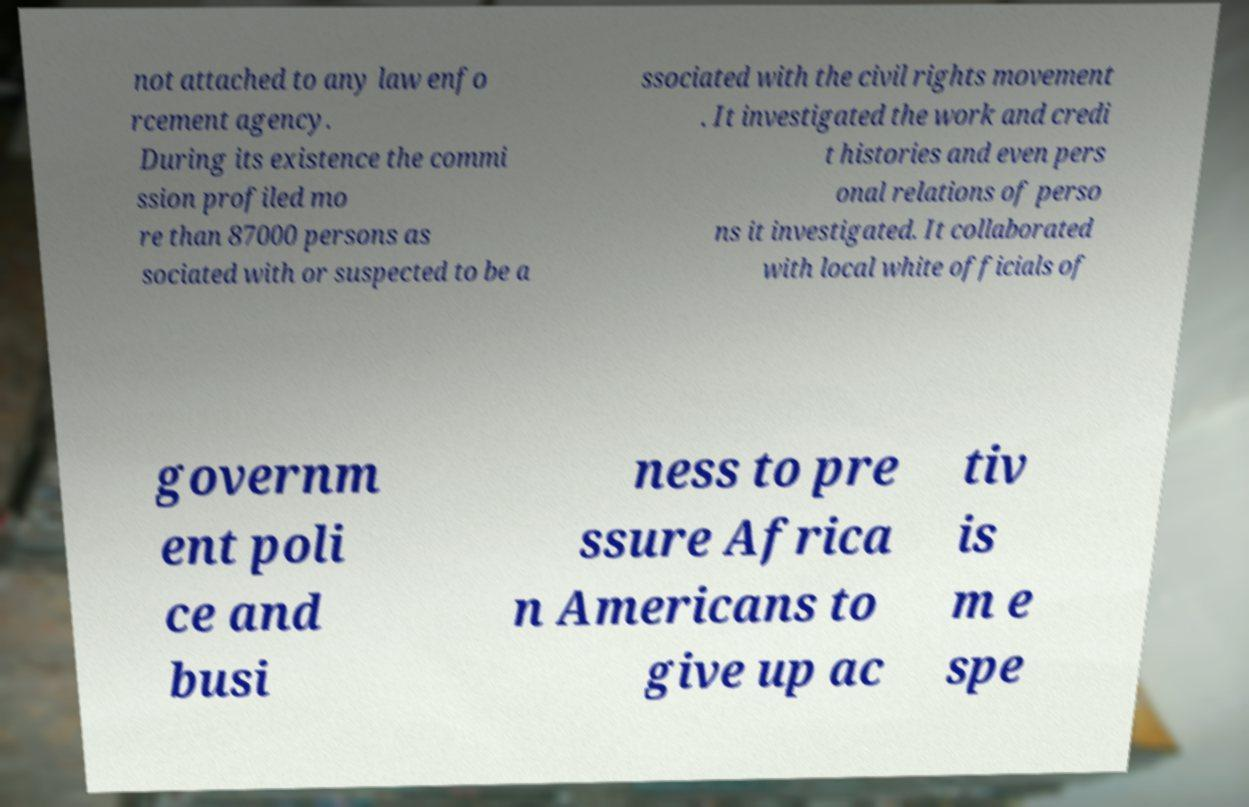There's text embedded in this image that I need extracted. Can you transcribe it verbatim? not attached to any law enfo rcement agency. During its existence the commi ssion profiled mo re than 87000 persons as sociated with or suspected to be a ssociated with the civil rights movement . It investigated the work and credi t histories and even pers onal relations of perso ns it investigated. It collaborated with local white officials of governm ent poli ce and busi ness to pre ssure Africa n Americans to give up ac tiv is m e spe 